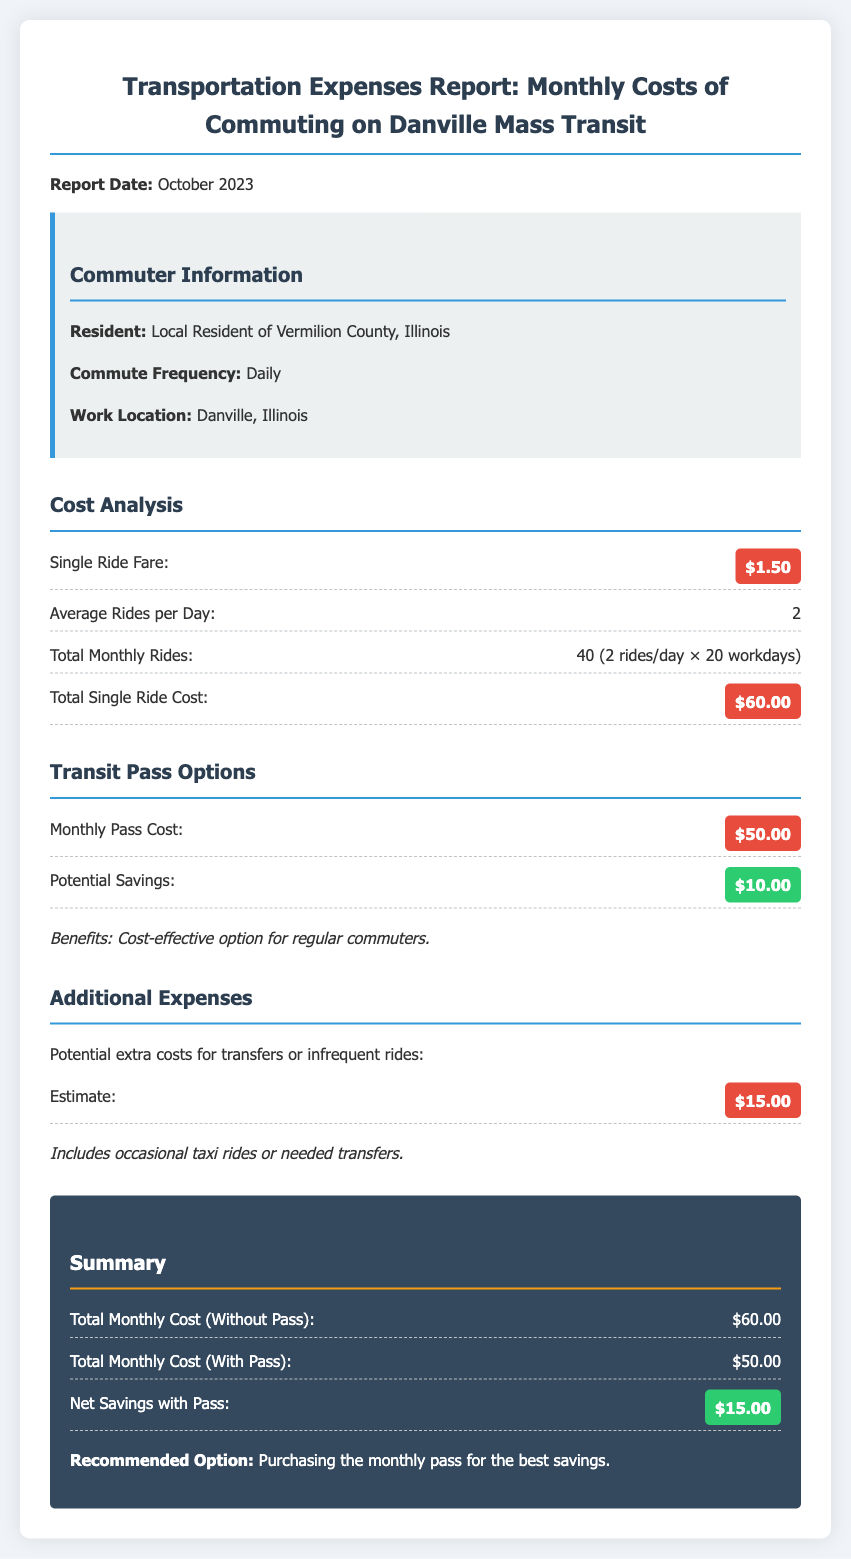What is the report date? The report date is specifically mentioned in the document, which is October 2023.
Answer: October 2023 What is the single ride fare? The document clearly states the single ride fare for Danville Mass Transit, which is $1.50.
Answer: $1.50 How many total rides per month are calculated? The total monthly rides are based on the average rides per day and the number of workdays, totaling 40 rides.
Answer: 40 What is the cost of the monthly pass? The cost of the monthly pass for Danville Mass Transit is listed in the document as $50.00.
Answer: $50.00 What is the total monthly cost without the pass? The total monthly cost without purchasing a pass is specified as $60.00.
Answer: $60.00 What are the estimated additional expenses? The document includes an estimate for potential extra costs, which is $15.00.
Answer: $15.00 What is the net savings with the monthly pass? The net savings from using the monthly pass instead of single rides is calculated in the document as $15.00.
Answer: $15.00 What is recommended for the best savings? The summary section of the report recommends purchasing a monthly pass for optimal cost savings.
Answer: Purchasing the monthly pass 